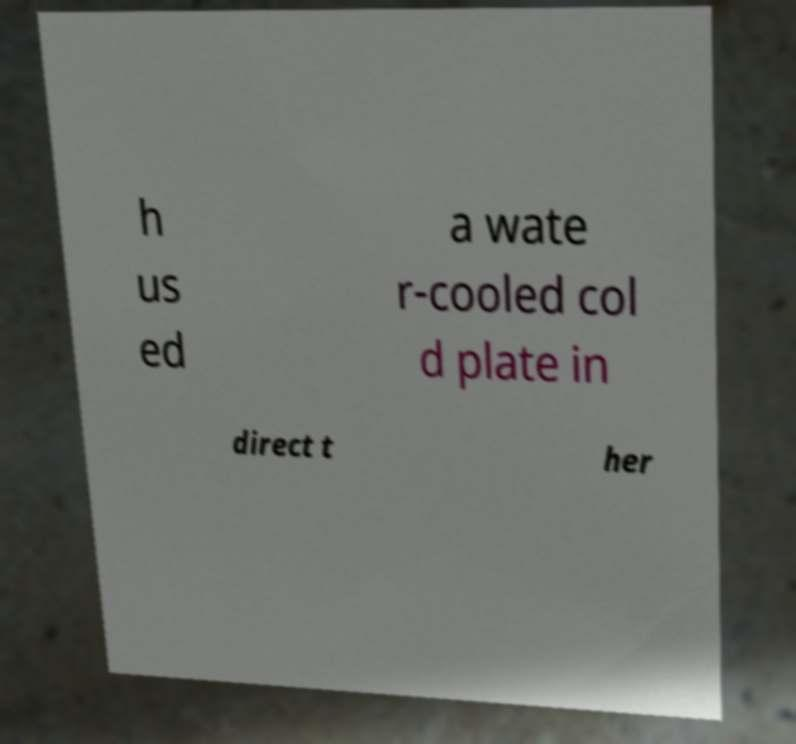There's text embedded in this image that I need extracted. Can you transcribe it verbatim? h us ed a wate r-cooled col d plate in direct t her 